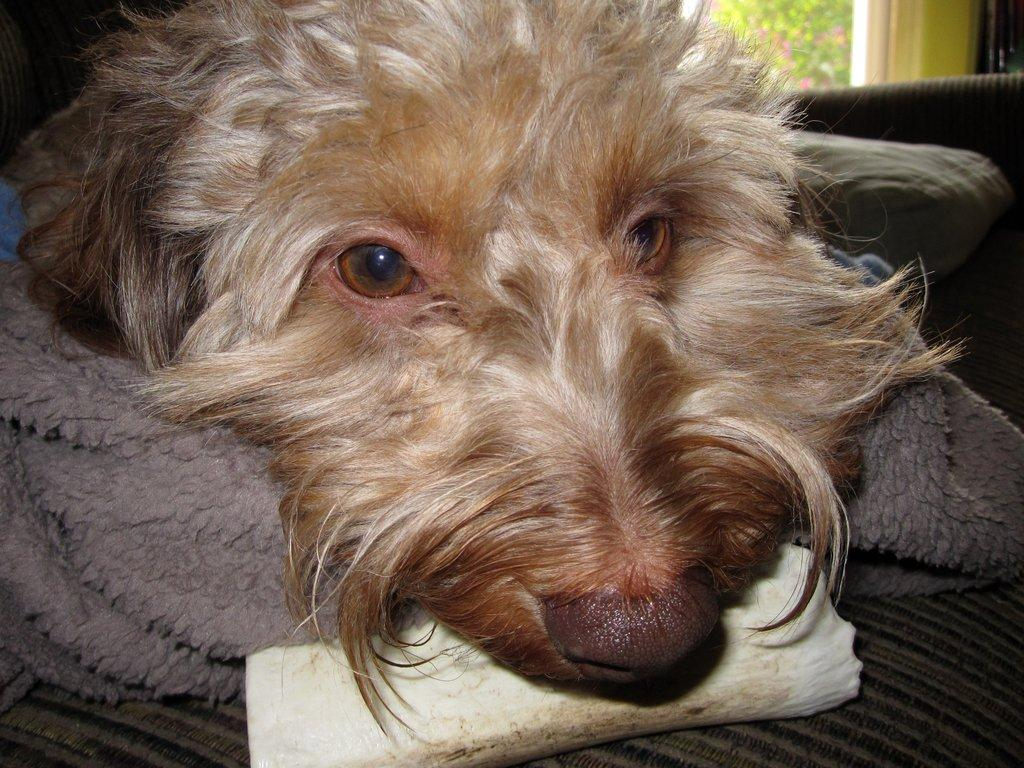What type of animal can be seen in the image? There is a dog in the image. What is the dog doing in the image? The dog is laying on a sofa. Is there anything covering the dog? Yes, there is a blanket above the dog. What can be seen on the right side of the image? There is a window visible on the right side of the image. What type of cord is being used to control the crowd in the image? There is no mention of a cord or a crowd in the image; it features a dog laying on a sofa with a blanket above it and a window visible on the right side. 